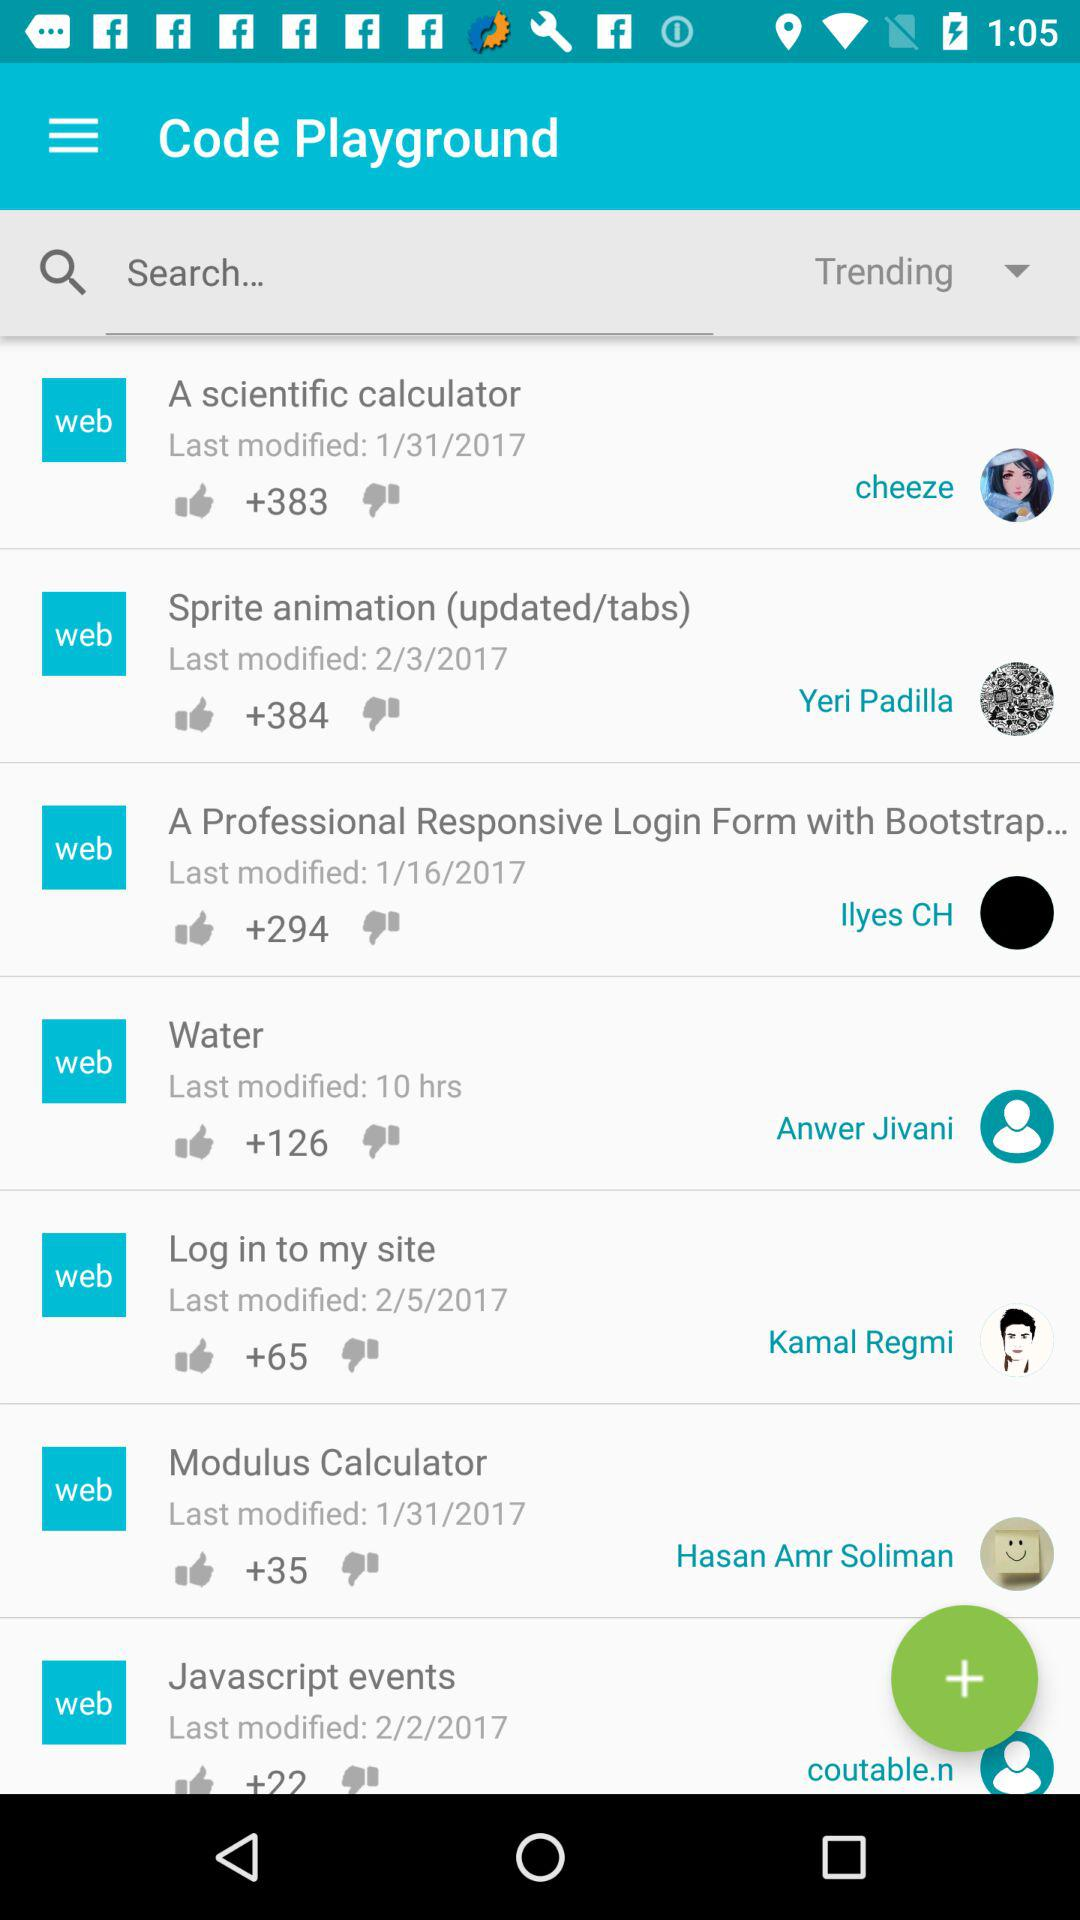What is the last modified date of "A scientific calculator"? The last modified date of "A scientific calculator" is January 31, 2017. 